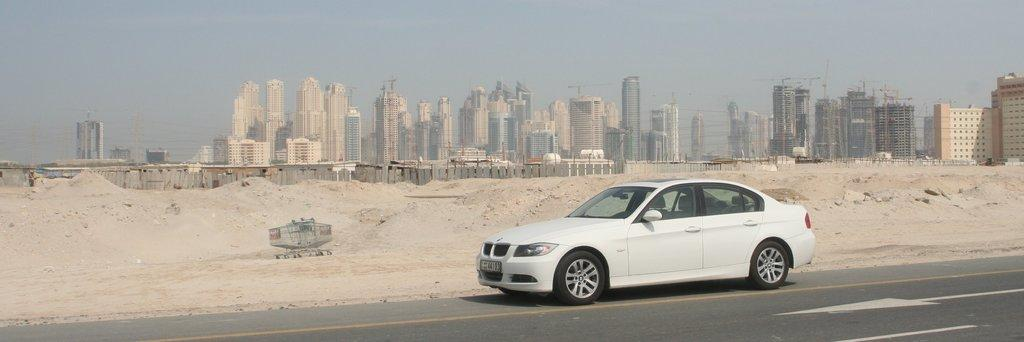What is in the foreground of the image? There is a road in the foreground of the image. What is on the road? There is a car on the road. What can be seen in the background of the image? There are tower buildings in the background of the image. What type of terrain is visible in the image? There is sand visible in the image. What is the purpose of the fence in the image? The fence in the image might be used to separate or enclose different areas. What type of egg is being used as a prop in the class in the image? There is no class or egg present in the image. What direction is the sun shining from in the image? There is no sun visible in the image. 